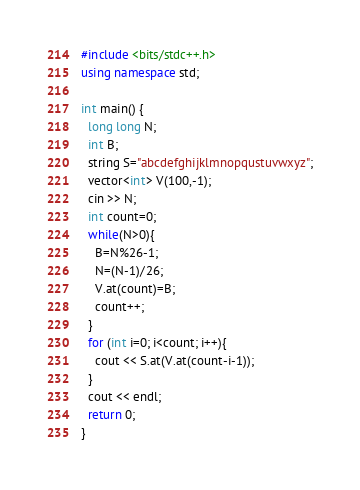Convert code to text. <code><loc_0><loc_0><loc_500><loc_500><_C++_>#include <bits/stdc++.h>
using namespace std;

int main() {
  long long N;
  int B;
  string S="abcdefghijklmnopqustuvwxyz";
  vector<int> V(100,-1);
  cin >> N;
  int count=0;
  while(N>0){
    B=N%26-1;
    N=(N-1)/26;
    V.at(count)=B;
    count++;
  }
  for (int i=0; i<count; i++){
    cout << S.at(V.at(count-i-1));
  }
  cout << endl;
  return 0;
}</code> 